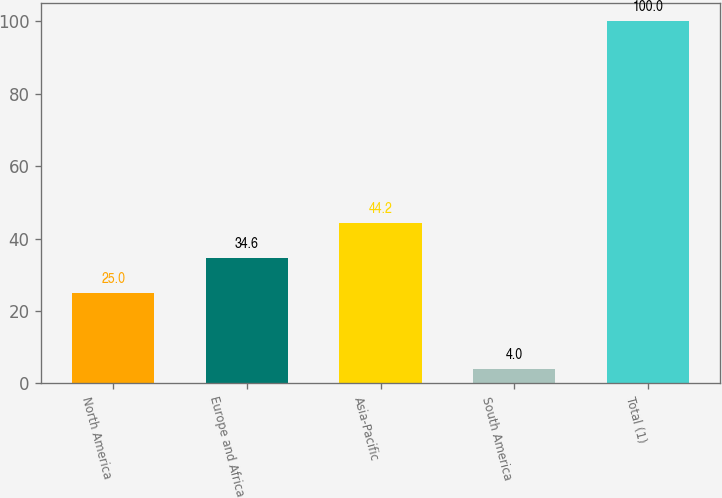Convert chart. <chart><loc_0><loc_0><loc_500><loc_500><bar_chart><fcel>North America<fcel>Europe and Africa<fcel>Asia-Pacific<fcel>South America<fcel>Total (1)<nl><fcel>25<fcel>34.6<fcel>44.2<fcel>4<fcel>100<nl></chart> 